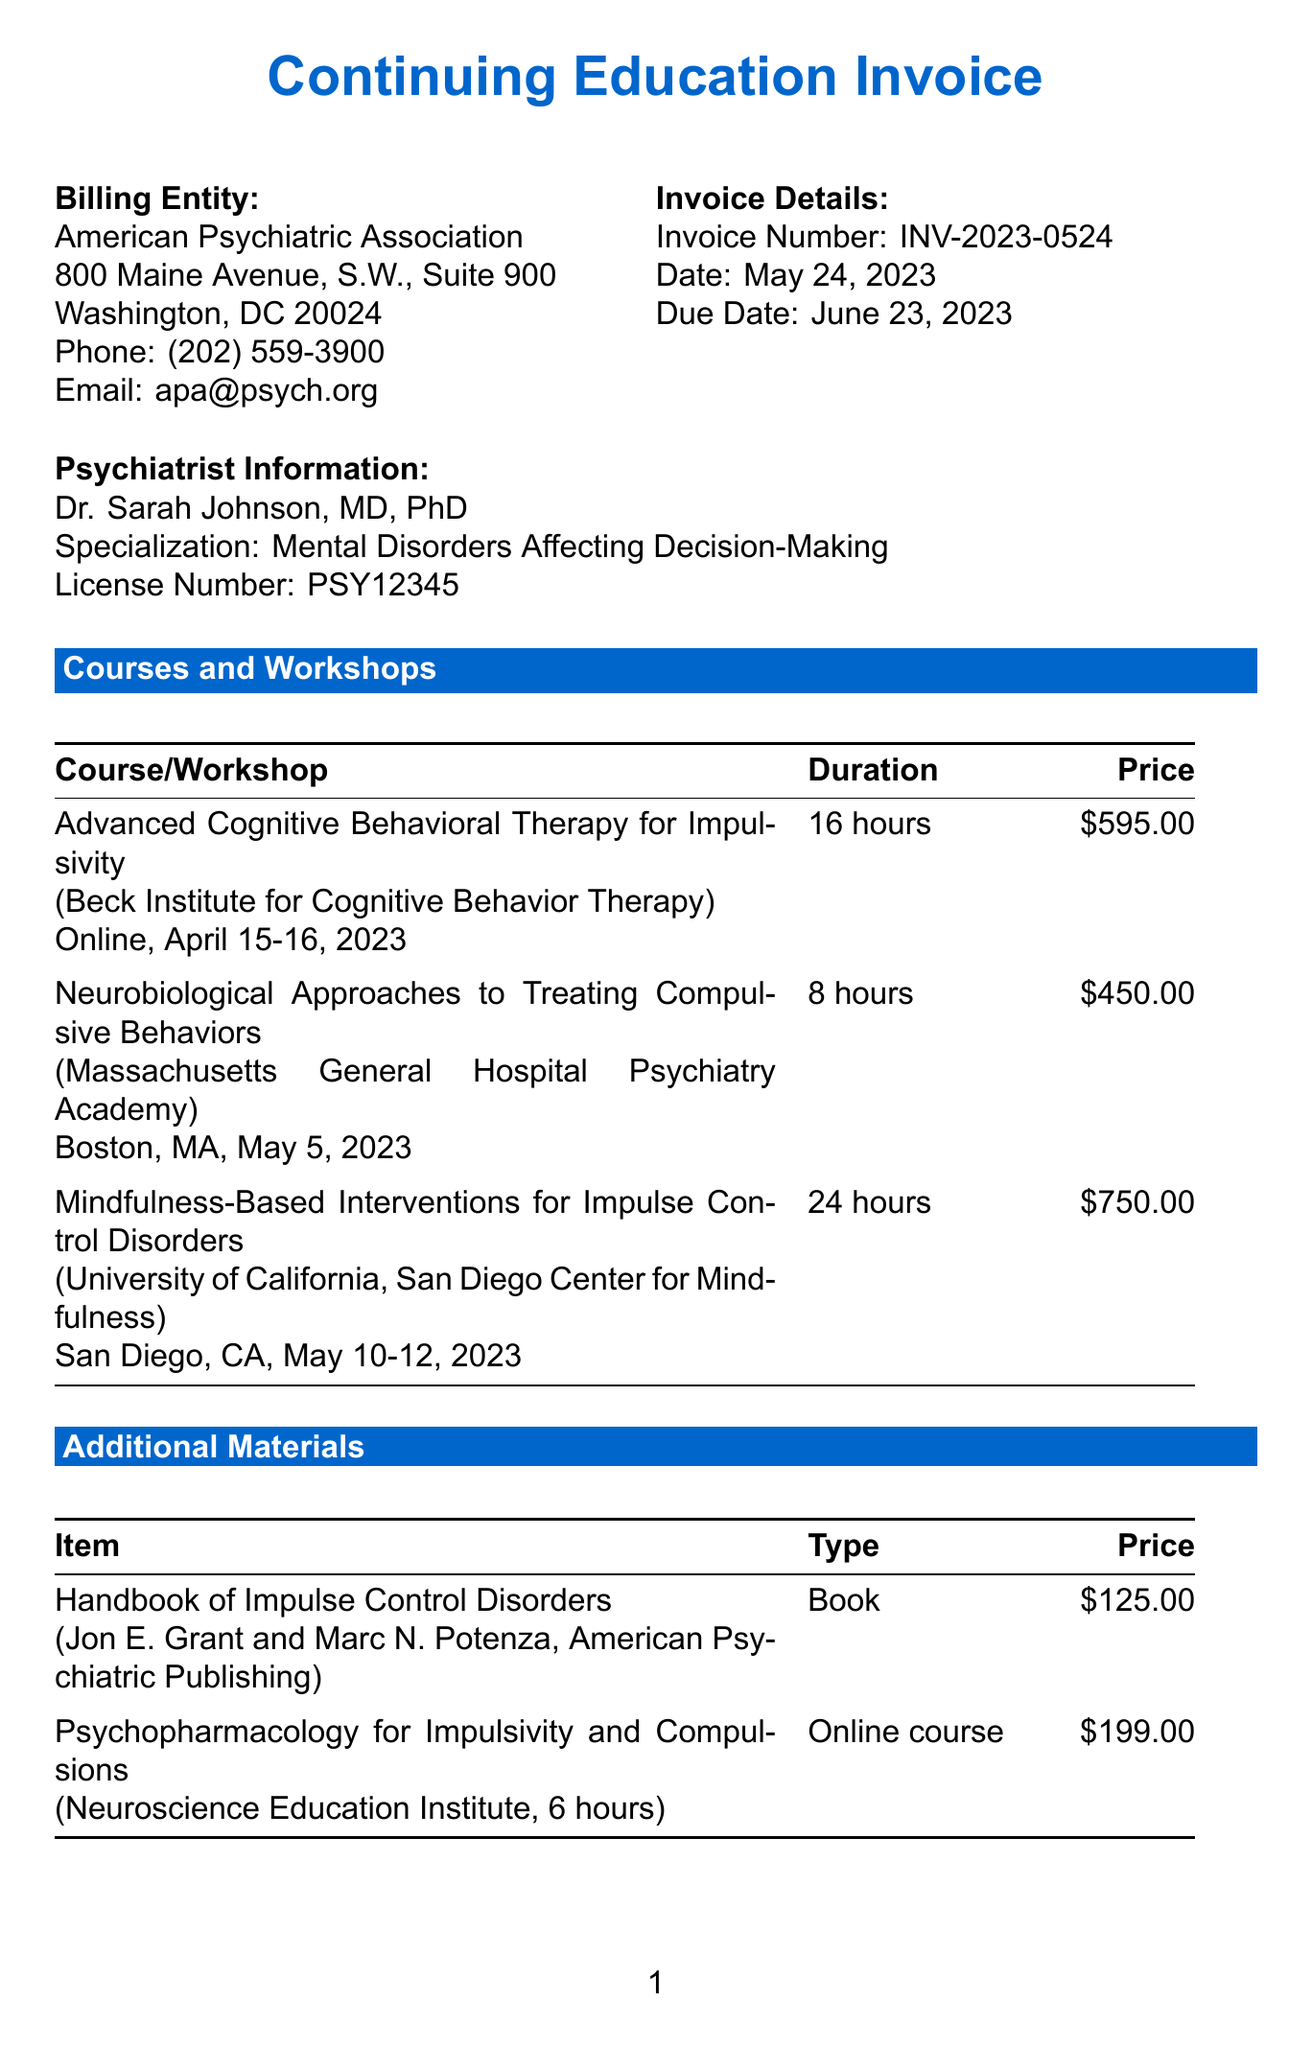What is the invoice number? The invoice number is specifically stated in the document as "INV-2023-0524."
Answer: INV-2023-0524 Who is the psychiatrist's name? The psychiatrist's name is listed in the document as "Dr. Sarah Johnson."
Answer: Dr. Sarah Johnson What is the total amount due? The total amount due is clearly indicated as "$2,246.14" in the document.
Answer: $2,246.14 How many hours is the "Mindfulness-Based Interventions for Impulse Control Disorders" course? The duration of this course is noted as "24 hours."
Answer: 24 hours What is the price of the "Handbook of Impulse Control Disorders"? The price for this item is given as "$125.00."
Answer: $125.00 What is the due date for the invoice? The due date is specifically mentioned in the document as "June 23, 2023."
Answer: June 23, 2023 Which organization provided the course on neurobiological approaches? The document states that this course is provided by "Massachusetts General Hospital Psychiatry Academy."
Answer: Massachusetts General Hospital Psychiatry Academy What percentage is the tax rate applied to the subtotal? The tax rate is indicated as "6%" in the document.
Answer: 6% What payment methods are accepted? The document lists "Credit Card, Bank Transfer, Check" as accepted payment methods.
Answer: Credit Card, Bank Transfer, Check 